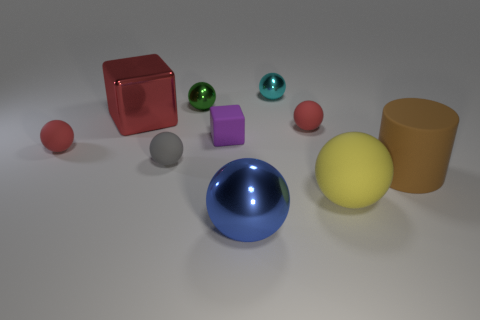What size is the green metallic thing that is the same shape as the tiny gray object?
Provide a succinct answer. Small. The large metal thing behind the tiny red rubber ball on the left side of the small purple rubber object is what shape?
Your answer should be very brief. Cube. Are there any other things that are the same color as the shiny block?
Your answer should be very brief. Yes. How many things are small cyan objects or big red shiny cylinders?
Offer a very short reply. 1. Are there any gray rubber cylinders that have the same size as the cyan thing?
Your answer should be very brief. No. What is the shape of the large yellow rubber object?
Offer a terse response. Sphere. Is the number of cyan metallic objects that are in front of the tiny cube greater than the number of cylinders on the left side of the big metal cube?
Keep it short and to the point. No. Is the color of the matte thing behind the tiny matte block the same as the big shiny object that is behind the large shiny sphere?
Provide a succinct answer. Yes. What is the shape of the brown thing that is the same size as the blue sphere?
Offer a terse response. Cylinder. Is there a small green metal object that has the same shape as the blue object?
Give a very brief answer. Yes. 